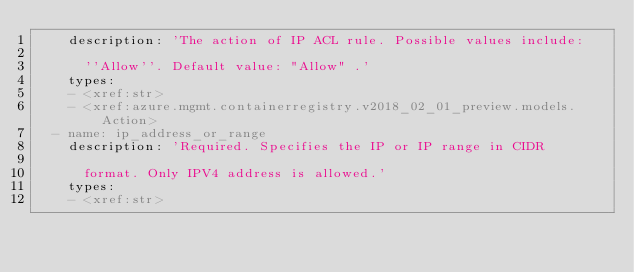Convert code to text. <code><loc_0><loc_0><loc_500><loc_500><_YAML_>    description: 'The action of IP ACL rule. Possible values include:

      ''Allow''. Default value: "Allow" .'
    types:
    - <xref:str>
    - <xref:azure.mgmt.containerregistry.v2018_02_01_preview.models.Action>
  - name: ip_address_or_range
    description: 'Required. Specifies the IP or IP range in CIDR

      format. Only IPV4 address is allowed.'
    types:
    - <xref:str>
</code> 